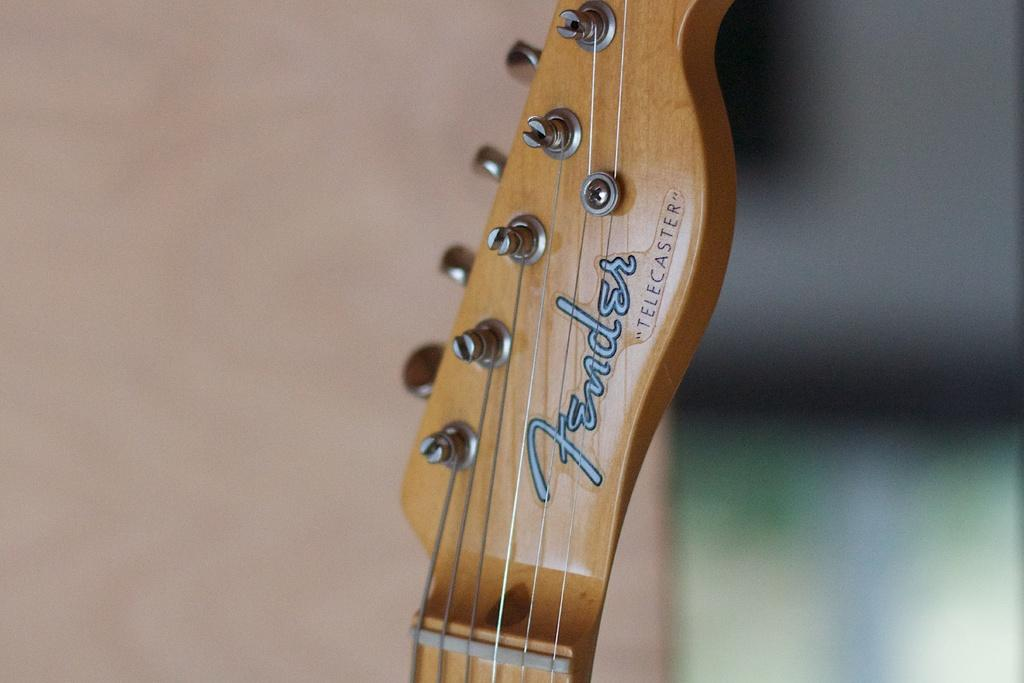What musical instrument is present in the image? There is a guitar in the image. What are the guitar's main components? The guitar has strings. Is there any writing or design on the guitar? Yes, there is text on the guitar. What type of advertisement can be seen on the truck in the image? There is no truck present in the image, and therefore no advertisement can be seen. 